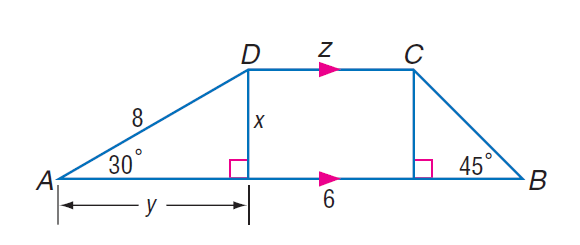Question: Find y.
Choices:
A. 4
B. 4 \sqrt { 3 }
C. 8
D. 8 \sqrt { 3 }
Answer with the letter. Answer: B Question: Find x.
Choices:
A. 4
B. 4 \sqrt { 3 }
C. 8
D. 6 \sqrt { 3 }
Answer with the letter. Answer: A 